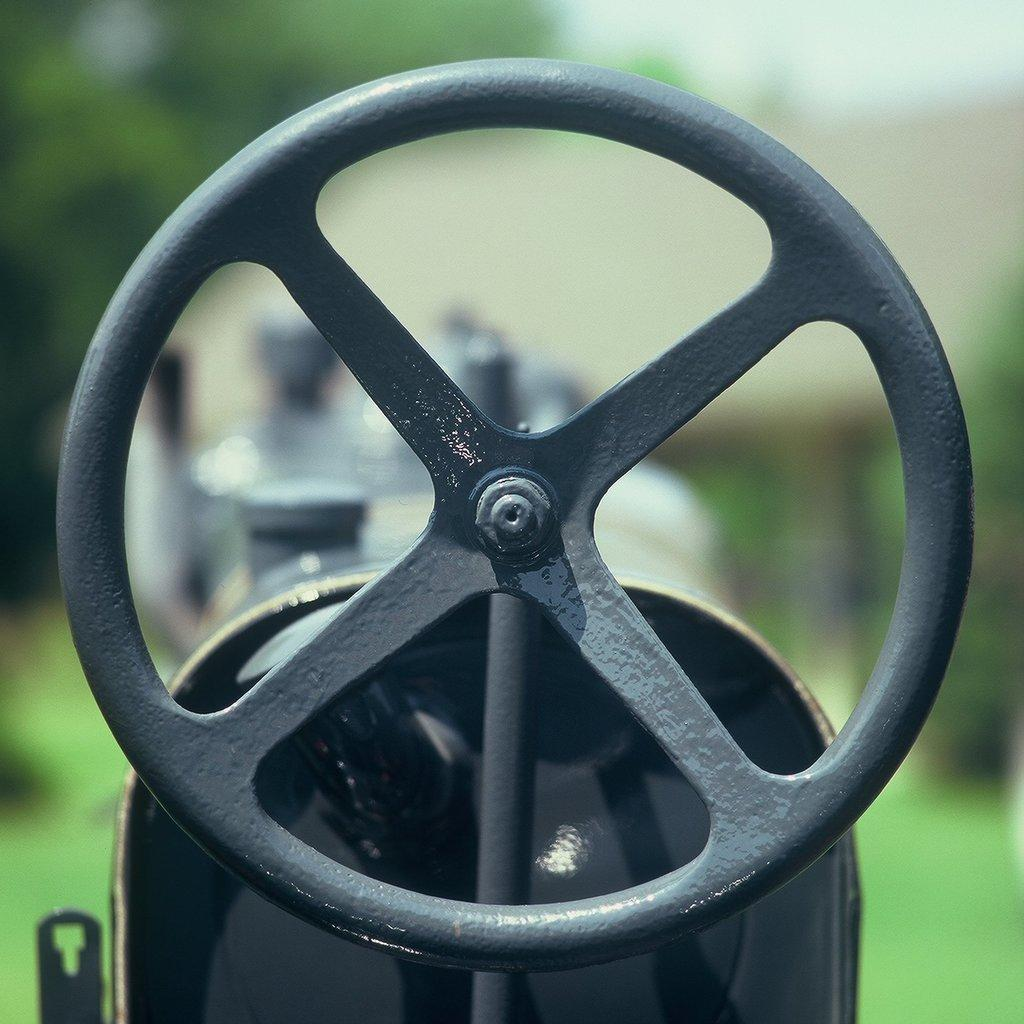What is the main object in the image? There is a machine lever in the image. Can you describe the background of the image? The background of the image is blurred. What type of knot can be seen in the image? There is no knot present in the image. Can you hear any sounds coming from the machine lever in the image? The image is not accompanied by any sounds, so it is not possible to hear any sounds coming from the machine lever. 